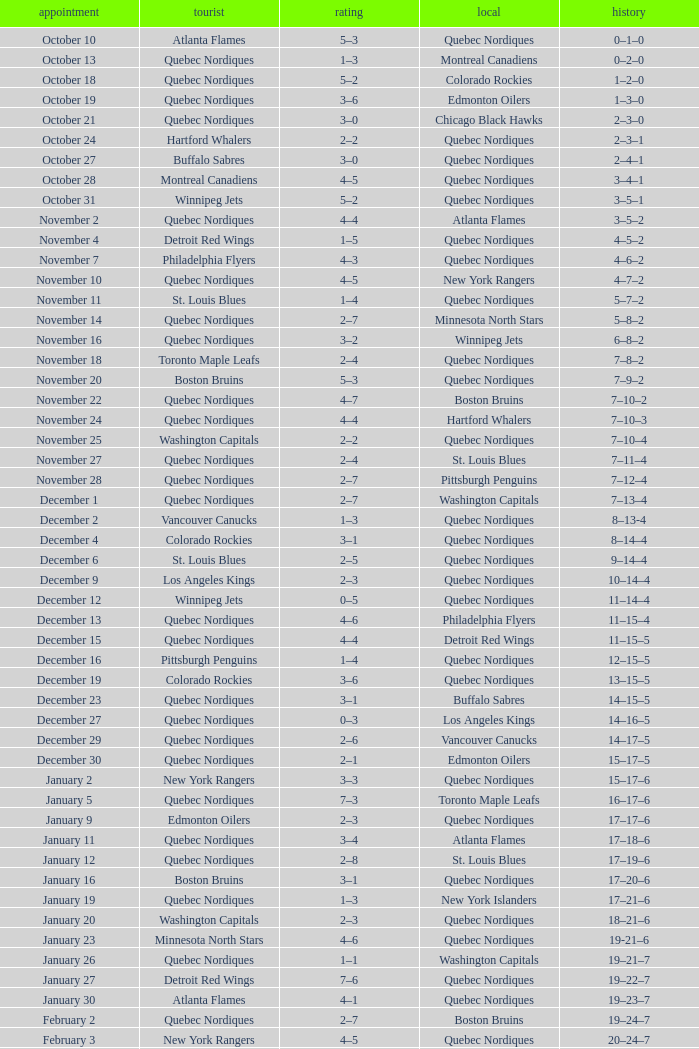Which Record has a Home of edmonton oilers, and a Score of 3–6? 1–3–0. 